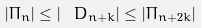Convert formula to latex. <formula><loc_0><loc_0><loc_500><loc_500>| \Pi _ { n } | \leq | \ D _ { n + k } | \leq | \Pi _ { n + 2 k } |</formula> 